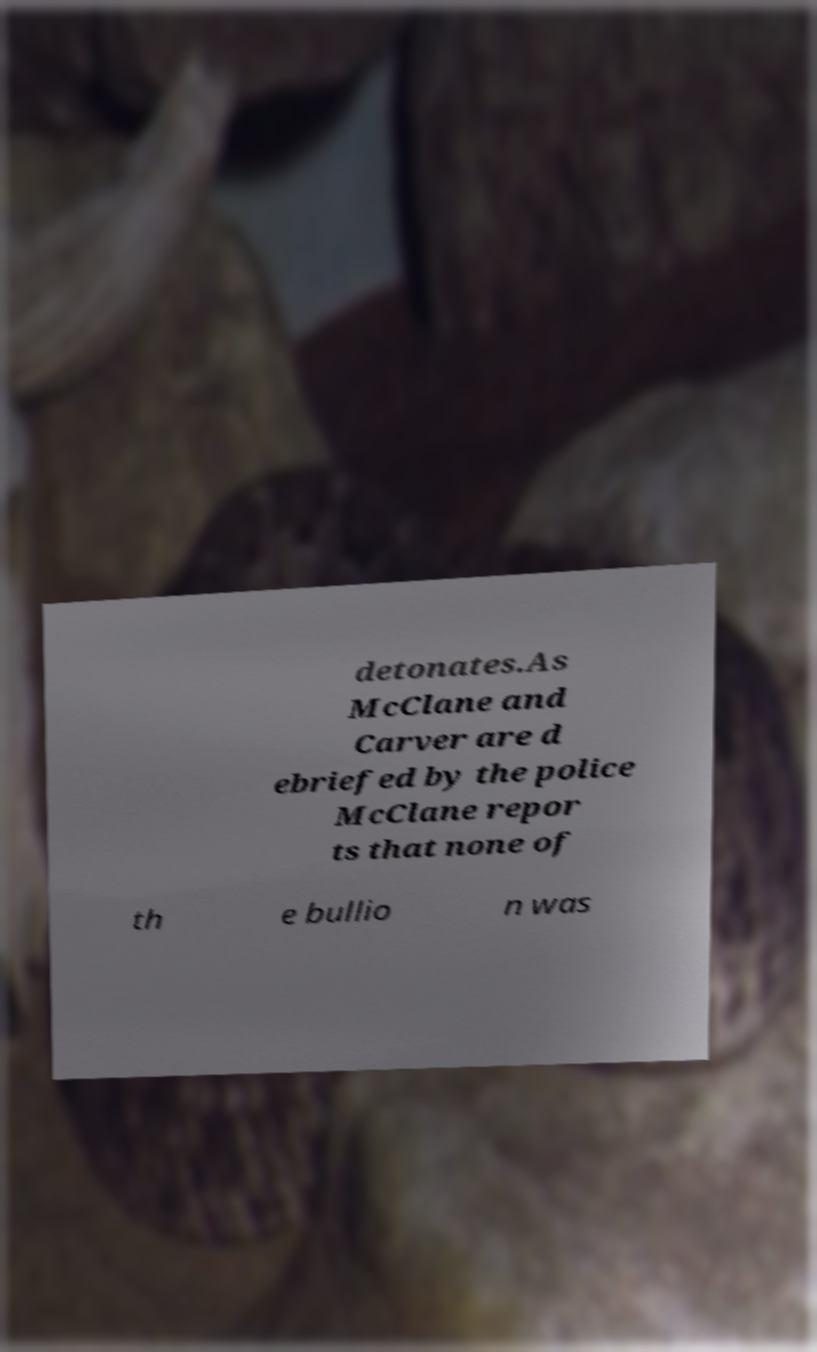For documentation purposes, I need the text within this image transcribed. Could you provide that? detonates.As McClane and Carver are d ebriefed by the police McClane repor ts that none of th e bullio n was 